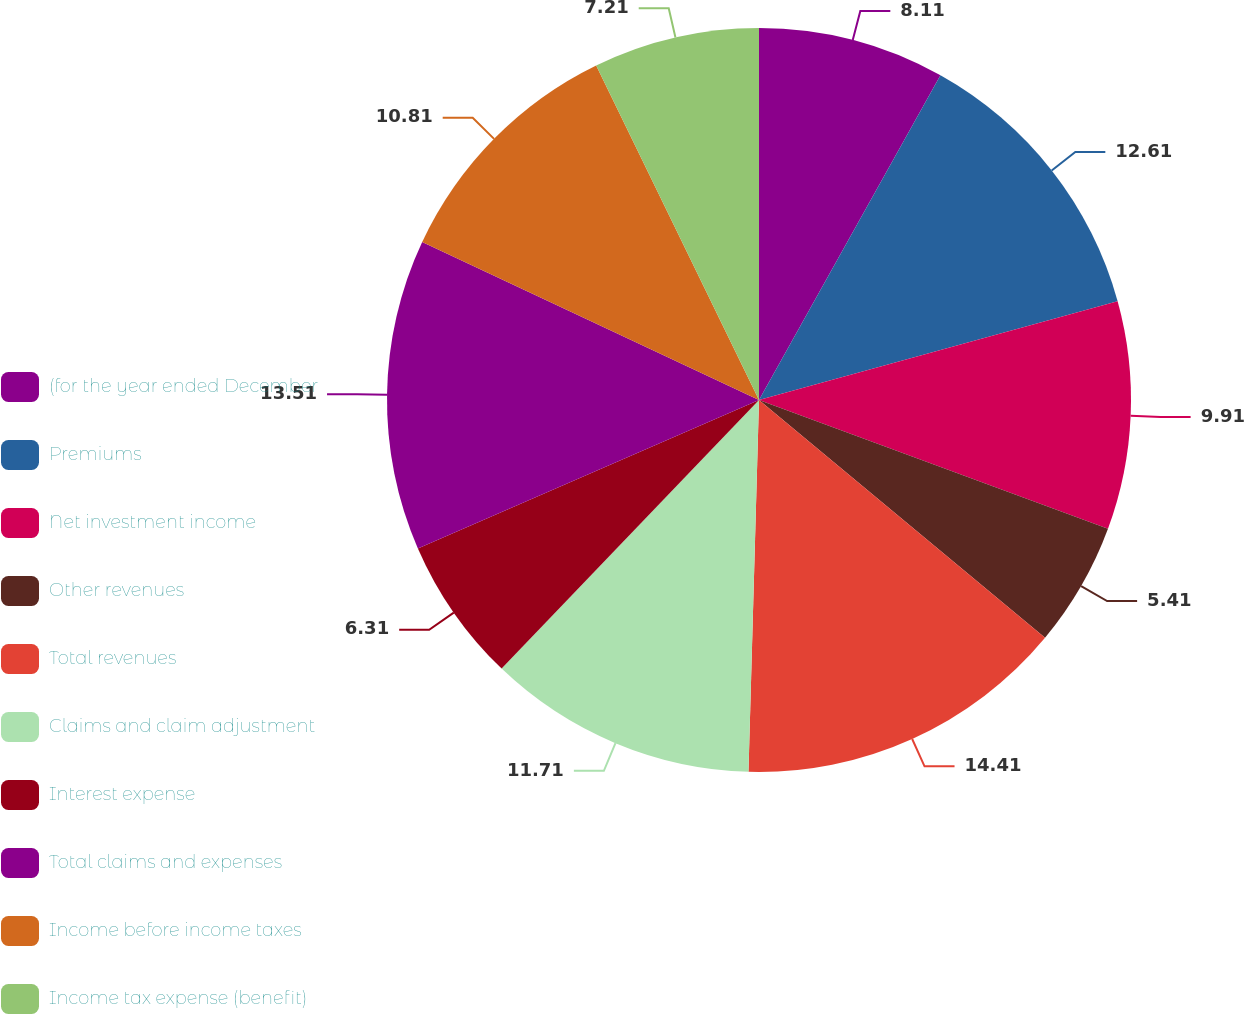Convert chart to OTSL. <chart><loc_0><loc_0><loc_500><loc_500><pie_chart><fcel>(for the year ended December<fcel>Premiums<fcel>Net investment income<fcel>Other revenues<fcel>Total revenues<fcel>Claims and claim adjustment<fcel>Interest expense<fcel>Total claims and expenses<fcel>Income before income taxes<fcel>Income tax expense (benefit)<nl><fcel>8.11%<fcel>12.61%<fcel>9.91%<fcel>5.41%<fcel>14.41%<fcel>11.71%<fcel>6.31%<fcel>13.51%<fcel>10.81%<fcel>7.21%<nl></chart> 